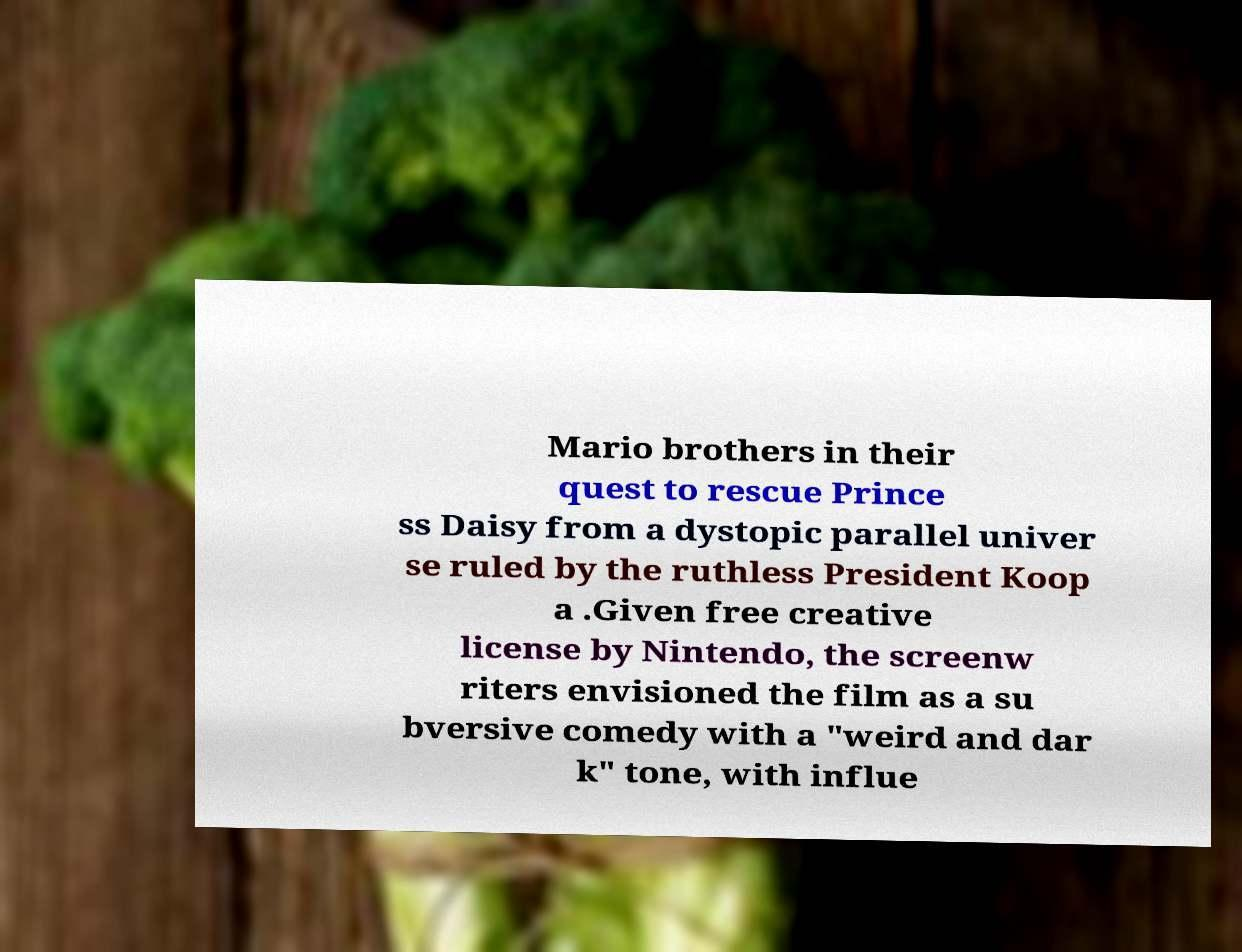What messages or text are displayed in this image? I need them in a readable, typed format. Mario brothers in their quest to rescue Prince ss Daisy from a dystopic parallel univer se ruled by the ruthless President Koop a .Given free creative license by Nintendo, the screenw riters envisioned the film as a su bversive comedy with a "weird and dar k" tone, with influe 